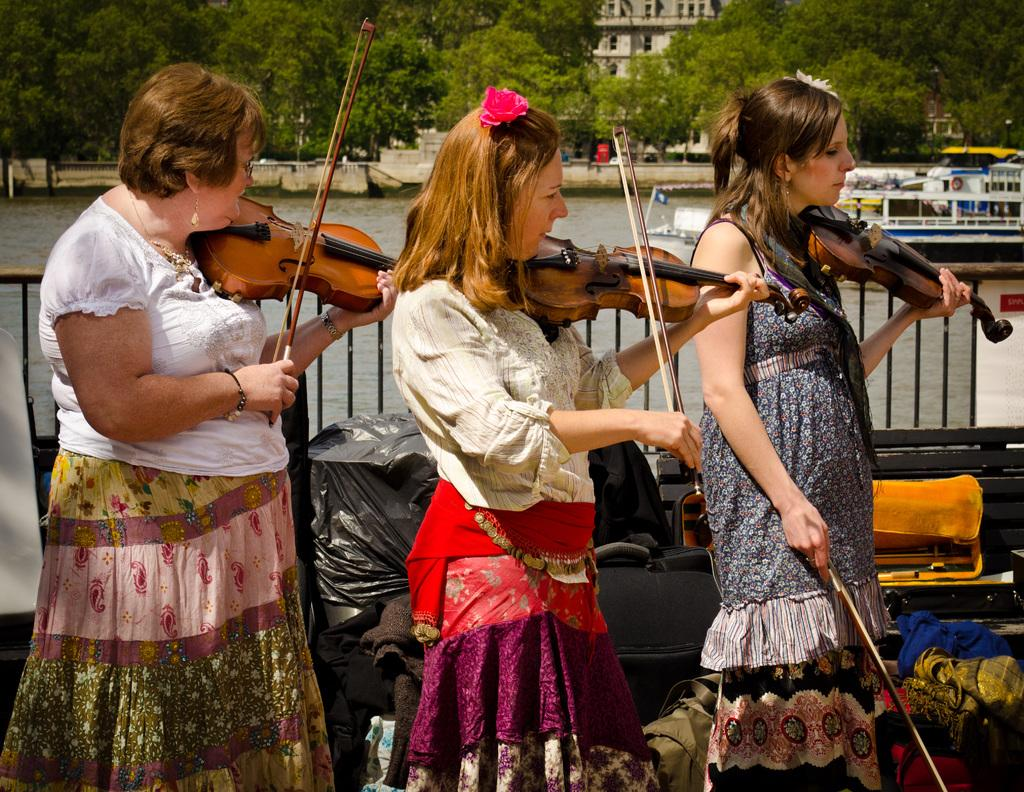How many ladies are present in the image? There are three ladies in the image. What are the ladies doing in the image? The ladies are holding guitars and playing them. What can be seen in the background of the image? There is a river, a boat, trees, and buildings in the background of the image. What type of grape is being used as a pick to play the guitar in the image? There is no grape being used as a pick in the image; the ladies are using their fingers or a guitar pick to play the guitars. Can you see any insects in the image? There are no insects visible in the image. 